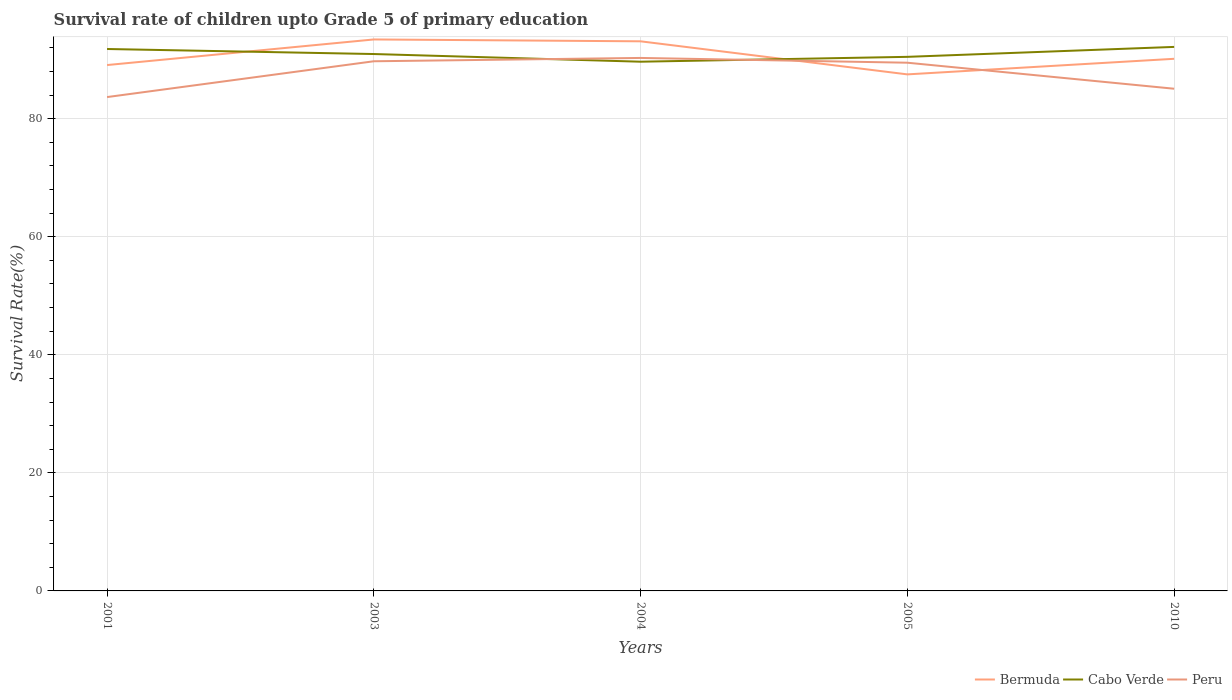Does the line corresponding to Bermuda intersect with the line corresponding to Peru?
Provide a succinct answer. Yes. Across all years, what is the maximum survival rate of children in Peru?
Your answer should be compact. 83.65. What is the total survival rate of children in Peru in the graph?
Your answer should be very brief. 5.22. What is the difference between the highest and the second highest survival rate of children in Bermuda?
Offer a terse response. 5.92. How many lines are there?
Provide a short and direct response. 3. How many years are there in the graph?
Your response must be concise. 5. Does the graph contain any zero values?
Give a very brief answer. No. Does the graph contain grids?
Provide a succinct answer. Yes. Where does the legend appear in the graph?
Provide a short and direct response. Bottom right. What is the title of the graph?
Keep it short and to the point. Survival rate of children upto Grade 5 of primary education. Does "Ukraine" appear as one of the legend labels in the graph?
Your response must be concise. No. What is the label or title of the Y-axis?
Provide a short and direct response. Survival Rate(%). What is the Survival Rate(%) in Bermuda in 2001?
Offer a very short reply. 89.07. What is the Survival Rate(%) of Cabo Verde in 2001?
Give a very brief answer. 91.79. What is the Survival Rate(%) in Peru in 2001?
Your answer should be compact. 83.65. What is the Survival Rate(%) of Bermuda in 2003?
Offer a very short reply. 93.41. What is the Survival Rate(%) in Cabo Verde in 2003?
Ensure brevity in your answer.  90.94. What is the Survival Rate(%) of Peru in 2003?
Make the answer very short. 89.72. What is the Survival Rate(%) of Bermuda in 2004?
Your answer should be very brief. 93.1. What is the Survival Rate(%) of Cabo Verde in 2004?
Keep it short and to the point. 89.64. What is the Survival Rate(%) in Peru in 2004?
Ensure brevity in your answer.  90.28. What is the Survival Rate(%) in Bermuda in 2005?
Offer a terse response. 87.5. What is the Survival Rate(%) of Cabo Verde in 2005?
Your response must be concise. 90.46. What is the Survival Rate(%) in Peru in 2005?
Your answer should be very brief. 89.47. What is the Survival Rate(%) of Bermuda in 2010?
Offer a terse response. 90.13. What is the Survival Rate(%) in Cabo Verde in 2010?
Offer a very short reply. 92.15. What is the Survival Rate(%) of Peru in 2010?
Give a very brief answer. 85.06. Across all years, what is the maximum Survival Rate(%) in Bermuda?
Offer a very short reply. 93.41. Across all years, what is the maximum Survival Rate(%) in Cabo Verde?
Offer a very short reply. 92.15. Across all years, what is the maximum Survival Rate(%) of Peru?
Provide a succinct answer. 90.28. Across all years, what is the minimum Survival Rate(%) in Bermuda?
Provide a succinct answer. 87.5. Across all years, what is the minimum Survival Rate(%) of Cabo Verde?
Offer a very short reply. 89.64. Across all years, what is the minimum Survival Rate(%) in Peru?
Keep it short and to the point. 83.65. What is the total Survival Rate(%) in Bermuda in the graph?
Your response must be concise. 453.21. What is the total Survival Rate(%) of Cabo Verde in the graph?
Offer a terse response. 454.99. What is the total Survival Rate(%) of Peru in the graph?
Offer a very short reply. 438.18. What is the difference between the Survival Rate(%) of Bermuda in 2001 and that in 2003?
Provide a short and direct response. -4.34. What is the difference between the Survival Rate(%) in Cabo Verde in 2001 and that in 2003?
Your answer should be very brief. 0.85. What is the difference between the Survival Rate(%) of Peru in 2001 and that in 2003?
Offer a very short reply. -6.06. What is the difference between the Survival Rate(%) of Bermuda in 2001 and that in 2004?
Give a very brief answer. -4.02. What is the difference between the Survival Rate(%) of Cabo Verde in 2001 and that in 2004?
Make the answer very short. 2.15. What is the difference between the Survival Rate(%) of Peru in 2001 and that in 2004?
Offer a very short reply. -6.63. What is the difference between the Survival Rate(%) in Bermuda in 2001 and that in 2005?
Ensure brevity in your answer.  1.58. What is the difference between the Survival Rate(%) of Cabo Verde in 2001 and that in 2005?
Give a very brief answer. 1.33. What is the difference between the Survival Rate(%) in Peru in 2001 and that in 2005?
Your response must be concise. -5.82. What is the difference between the Survival Rate(%) of Bermuda in 2001 and that in 2010?
Make the answer very short. -1.06. What is the difference between the Survival Rate(%) in Cabo Verde in 2001 and that in 2010?
Make the answer very short. -0.35. What is the difference between the Survival Rate(%) in Peru in 2001 and that in 2010?
Offer a very short reply. -1.41. What is the difference between the Survival Rate(%) of Bermuda in 2003 and that in 2004?
Your answer should be compact. 0.32. What is the difference between the Survival Rate(%) of Cabo Verde in 2003 and that in 2004?
Ensure brevity in your answer.  1.3. What is the difference between the Survival Rate(%) of Peru in 2003 and that in 2004?
Your answer should be very brief. -0.56. What is the difference between the Survival Rate(%) of Bermuda in 2003 and that in 2005?
Provide a succinct answer. 5.92. What is the difference between the Survival Rate(%) in Cabo Verde in 2003 and that in 2005?
Your answer should be very brief. 0.48. What is the difference between the Survival Rate(%) in Peru in 2003 and that in 2005?
Ensure brevity in your answer.  0.25. What is the difference between the Survival Rate(%) in Bermuda in 2003 and that in 2010?
Give a very brief answer. 3.28. What is the difference between the Survival Rate(%) in Cabo Verde in 2003 and that in 2010?
Make the answer very short. -1.21. What is the difference between the Survival Rate(%) of Peru in 2003 and that in 2010?
Provide a succinct answer. 4.65. What is the difference between the Survival Rate(%) in Bermuda in 2004 and that in 2005?
Offer a terse response. 5.6. What is the difference between the Survival Rate(%) in Cabo Verde in 2004 and that in 2005?
Ensure brevity in your answer.  -0.82. What is the difference between the Survival Rate(%) in Peru in 2004 and that in 2005?
Make the answer very short. 0.81. What is the difference between the Survival Rate(%) of Bermuda in 2004 and that in 2010?
Your answer should be compact. 2.96. What is the difference between the Survival Rate(%) in Cabo Verde in 2004 and that in 2010?
Give a very brief answer. -2.51. What is the difference between the Survival Rate(%) of Peru in 2004 and that in 2010?
Offer a terse response. 5.22. What is the difference between the Survival Rate(%) of Bermuda in 2005 and that in 2010?
Offer a terse response. -2.64. What is the difference between the Survival Rate(%) of Cabo Verde in 2005 and that in 2010?
Offer a very short reply. -1.68. What is the difference between the Survival Rate(%) of Peru in 2005 and that in 2010?
Keep it short and to the point. 4.41. What is the difference between the Survival Rate(%) in Bermuda in 2001 and the Survival Rate(%) in Cabo Verde in 2003?
Provide a succinct answer. -1.87. What is the difference between the Survival Rate(%) in Bermuda in 2001 and the Survival Rate(%) in Peru in 2003?
Your answer should be compact. -0.64. What is the difference between the Survival Rate(%) in Cabo Verde in 2001 and the Survival Rate(%) in Peru in 2003?
Make the answer very short. 2.08. What is the difference between the Survival Rate(%) of Bermuda in 2001 and the Survival Rate(%) of Cabo Verde in 2004?
Provide a short and direct response. -0.57. What is the difference between the Survival Rate(%) in Bermuda in 2001 and the Survival Rate(%) in Peru in 2004?
Keep it short and to the point. -1.2. What is the difference between the Survival Rate(%) of Cabo Verde in 2001 and the Survival Rate(%) of Peru in 2004?
Your answer should be very brief. 1.52. What is the difference between the Survival Rate(%) in Bermuda in 2001 and the Survival Rate(%) in Cabo Verde in 2005?
Keep it short and to the point. -1.39. What is the difference between the Survival Rate(%) in Bermuda in 2001 and the Survival Rate(%) in Peru in 2005?
Your answer should be compact. -0.4. What is the difference between the Survival Rate(%) of Cabo Verde in 2001 and the Survival Rate(%) of Peru in 2005?
Provide a short and direct response. 2.32. What is the difference between the Survival Rate(%) of Bermuda in 2001 and the Survival Rate(%) of Cabo Verde in 2010?
Your response must be concise. -3.07. What is the difference between the Survival Rate(%) of Bermuda in 2001 and the Survival Rate(%) of Peru in 2010?
Keep it short and to the point. 4.01. What is the difference between the Survival Rate(%) of Cabo Verde in 2001 and the Survival Rate(%) of Peru in 2010?
Your response must be concise. 6.73. What is the difference between the Survival Rate(%) in Bermuda in 2003 and the Survival Rate(%) in Cabo Verde in 2004?
Make the answer very short. 3.77. What is the difference between the Survival Rate(%) in Bermuda in 2003 and the Survival Rate(%) in Peru in 2004?
Offer a terse response. 3.13. What is the difference between the Survival Rate(%) of Cabo Verde in 2003 and the Survival Rate(%) of Peru in 2004?
Ensure brevity in your answer.  0.66. What is the difference between the Survival Rate(%) in Bermuda in 2003 and the Survival Rate(%) in Cabo Verde in 2005?
Make the answer very short. 2.95. What is the difference between the Survival Rate(%) of Bermuda in 2003 and the Survival Rate(%) of Peru in 2005?
Your response must be concise. 3.94. What is the difference between the Survival Rate(%) in Cabo Verde in 2003 and the Survival Rate(%) in Peru in 2005?
Give a very brief answer. 1.47. What is the difference between the Survival Rate(%) in Bermuda in 2003 and the Survival Rate(%) in Cabo Verde in 2010?
Your answer should be very brief. 1.26. What is the difference between the Survival Rate(%) of Bermuda in 2003 and the Survival Rate(%) of Peru in 2010?
Ensure brevity in your answer.  8.35. What is the difference between the Survival Rate(%) of Cabo Verde in 2003 and the Survival Rate(%) of Peru in 2010?
Provide a succinct answer. 5.88. What is the difference between the Survival Rate(%) in Bermuda in 2004 and the Survival Rate(%) in Cabo Verde in 2005?
Your answer should be very brief. 2.63. What is the difference between the Survival Rate(%) in Bermuda in 2004 and the Survival Rate(%) in Peru in 2005?
Offer a very short reply. 3.62. What is the difference between the Survival Rate(%) of Cabo Verde in 2004 and the Survival Rate(%) of Peru in 2005?
Give a very brief answer. 0.17. What is the difference between the Survival Rate(%) of Bermuda in 2004 and the Survival Rate(%) of Cabo Verde in 2010?
Give a very brief answer. 0.95. What is the difference between the Survival Rate(%) of Bermuda in 2004 and the Survival Rate(%) of Peru in 2010?
Offer a terse response. 8.03. What is the difference between the Survival Rate(%) of Cabo Verde in 2004 and the Survival Rate(%) of Peru in 2010?
Make the answer very short. 4.58. What is the difference between the Survival Rate(%) in Bermuda in 2005 and the Survival Rate(%) in Cabo Verde in 2010?
Provide a short and direct response. -4.65. What is the difference between the Survival Rate(%) of Bermuda in 2005 and the Survival Rate(%) of Peru in 2010?
Your response must be concise. 2.43. What is the difference between the Survival Rate(%) of Cabo Verde in 2005 and the Survival Rate(%) of Peru in 2010?
Ensure brevity in your answer.  5.4. What is the average Survival Rate(%) of Bermuda per year?
Your answer should be compact. 90.64. What is the average Survival Rate(%) of Cabo Verde per year?
Keep it short and to the point. 91. What is the average Survival Rate(%) of Peru per year?
Your answer should be very brief. 87.64. In the year 2001, what is the difference between the Survival Rate(%) of Bermuda and Survival Rate(%) of Cabo Verde?
Your answer should be compact. -2.72. In the year 2001, what is the difference between the Survival Rate(%) in Bermuda and Survival Rate(%) in Peru?
Your answer should be compact. 5.42. In the year 2001, what is the difference between the Survival Rate(%) in Cabo Verde and Survival Rate(%) in Peru?
Provide a short and direct response. 8.14. In the year 2003, what is the difference between the Survival Rate(%) in Bermuda and Survival Rate(%) in Cabo Verde?
Your answer should be very brief. 2.47. In the year 2003, what is the difference between the Survival Rate(%) of Bermuda and Survival Rate(%) of Peru?
Your answer should be compact. 3.69. In the year 2003, what is the difference between the Survival Rate(%) of Cabo Verde and Survival Rate(%) of Peru?
Ensure brevity in your answer.  1.23. In the year 2004, what is the difference between the Survival Rate(%) of Bermuda and Survival Rate(%) of Cabo Verde?
Offer a very short reply. 3.45. In the year 2004, what is the difference between the Survival Rate(%) of Bermuda and Survival Rate(%) of Peru?
Provide a succinct answer. 2.82. In the year 2004, what is the difference between the Survival Rate(%) in Cabo Verde and Survival Rate(%) in Peru?
Your response must be concise. -0.64. In the year 2005, what is the difference between the Survival Rate(%) of Bermuda and Survival Rate(%) of Cabo Verde?
Keep it short and to the point. -2.97. In the year 2005, what is the difference between the Survival Rate(%) of Bermuda and Survival Rate(%) of Peru?
Provide a short and direct response. -1.98. In the year 2010, what is the difference between the Survival Rate(%) in Bermuda and Survival Rate(%) in Cabo Verde?
Give a very brief answer. -2.01. In the year 2010, what is the difference between the Survival Rate(%) in Bermuda and Survival Rate(%) in Peru?
Your answer should be compact. 5.07. In the year 2010, what is the difference between the Survival Rate(%) in Cabo Verde and Survival Rate(%) in Peru?
Provide a succinct answer. 7.08. What is the ratio of the Survival Rate(%) in Bermuda in 2001 to that in 2003?
Provide a short and direct response. 0.95. What is the ratio of the Survival Rate(%) of Cabo Verde in 2001 to that in 2003?
Give a very brief answer. 1.01. What is the ratio of the Survival Rate(%) in Peru in 2001 to that in 2003?
Keep it short and to the point. 0.93. What is the ratio of the Survival Rate(%) of Bermuda in 2001 to that in 2004?
Make the answer very short. 0.96. What is the ratio of the Survival Rate(%) of Peru in 2001 to that in 2004?
Your answer should be very brief. 0.93. What is the ratio of the Survival Rate(%) of Bermuda in 2001 to that in 2005?
Your response must be concise. 1.02. What is the ratio of the Survival Rate(%) of Cabo Verde in 2001 to that in 2005?
Give a very brief answer. 1.01. What is the ratio of the Survival Rate(%) of Peru in 2001 to that in 2005?
Offer a terse response. 0.94. What is the ratio of the Survival Rate(%) in Bermuda in 2001 to that in 2010?
Ensure brevity in your answer.  0.99. What is the ratio of the Survival Rate(%) in Cabo Verde in 2001 to that in 2010?
Offer a very short reply. 1. What is the ratio of the Survival Rate(%) in Peru in 2001 to that in 2010?
Offer a very short reply. 0.98. What is the ratio of the Survival Rate(%) in Bermuda in 2003 to that in 2004?
Ensure brevity in your answer.  1. What is the ratio of the Survival Rate(%) in Cabo Verde in 2003 to that in 2004?
Your answer should be compact. 1.01. What is the ratio of the Survival Rate(%) of Bermuda in 2003 to that in 2005?
Offer a terse response. 1.07. What is the ratio of the Survival Rate(%) in Peru in 2003 to that in 2005?
Your answer should be very brief. 1. What is the ratio of the Survival Rate(%) of Bermuda in 2003 to that in 2010?
Offer a terse response. 1.04. What is the ratio of the Survival Rate(%) in Cabo Verde in 2003 to that in 2010?
Your answer should be very brief. 0.99. What is the ratio of the Survival Rate(%) in Peru in 2003 to that in 2010?
Ensure brevity in your answer.  1.05. What is the ratio of the Survival Rate(%) in Bermuda in 2004 to that in 2005?
Offer a terse response. 1.06. What is the ratio of the Survival Rate(%) in Cabo Verde in 2004 to that in 2005?
Your answer should be very brief. 0.99. What is the ratio of the Survival Rate(%) of Bermuda in 2004 to that in 2010?
Offer a terse response. 1.03. What is the ratio of the Survival Rate(%) in Cabo Verde in 2004 to that in 2010?
Keep it short and to the point. 0.97. What is the ratio of the Survival Rate(%) of Peru in 2004 to that in 2010?
Give a very brief answer. 1.06. What is the ratio of the Survival Rate(%) in Bermuda in 2005 to that in 2010?
Give a very brief answer. 0.97. What is the ratio of the Survival Rate(%) of Cabo Verde in 2005 to that in 2010?
Give a very brief answer. 0.98. What is the ratio of the Survival Rate(%) of Peru in 2005 to that in 2010?
Offer a terse response. 1.05. What is the difference between the highest and the second highest Survival Rate(%) of Bermuda?
Offer a terse response. 0.32. What is the difference between the highest and the second highest Survival Rate(%) of Cabo Verde?
Your answer should be very brief. 0.35. What is the difference between the highest and the second highest Survival Rate(%) of Peru?
Your response must be concise. 0.56. What is the difference between the highest and the lowest Survival Rate(%) of Bermuda?
Make the answer very short. 5.92. What is the difference between the highest and the lowest Survival Rate(%) in Cabo Verde?
Offer a very short reply. 2.51. What is the difference between the highest and the lowest Survival Rate(%) in Peru?
Make the answer very short. 6.63. 